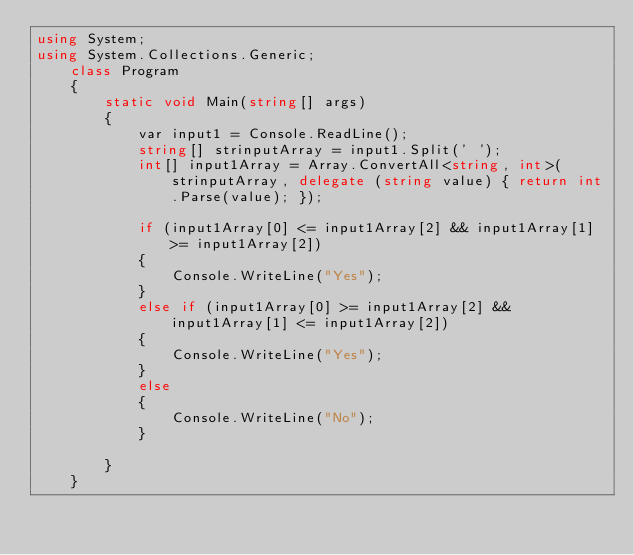Convert code to text. <code><loc_0><loc_0><loc_500><loc_500><_C#_>using System;
using System.Collections.Generic;
    class Program
    {
        static void Main(string[] args)
        {
            var input1 = Console.ReadLine();
            string[] strinputArray = input1.Split(' ');
            int[] input1Array = Array.ConvertAll<string, int>(strinputArray, delegate (string value) { return int.Parse(value); });

            if (input1Array[0] <= input1Array[2] && input1Array[1] >= input1Array[2])
            {
                Console.WriteLine("Yes");
            }
            else if (input1Array[0] >= input1Array[2] && input1Array[1] <= input1Array[2])
            {
                Console.WriteLine("Yes");
            }
            else
            {
                Console.WriteLine("No");
            }

        }
    }</code> 